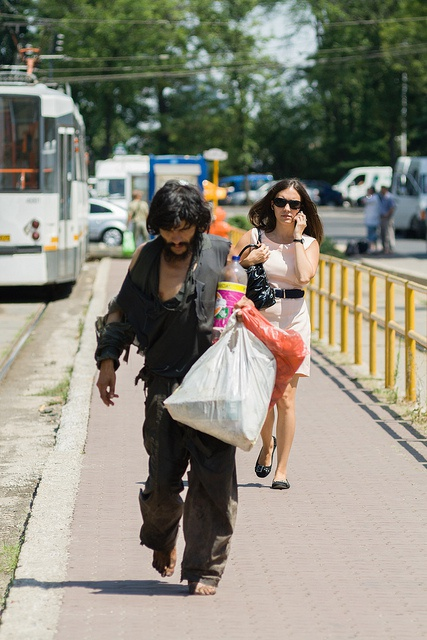Describe the objects in this image and their specific colors. I can see people in black, gray, and maroon tones, train in black, lightgray, gray, and darkgray tones, bus in black, lightgray, darkgray, and gray tones, people in black, tan, lightgray, and gray tones, and truck in black and gray tones in this image. 